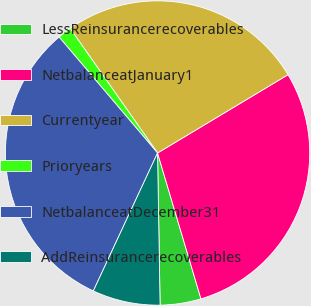Convert chart to OTSL. <chart><loc_0><loc_0><loc_500><loc_500><pie_chart><fcel>LessReinsurancerecoverables<fcel>NetbalanceatJanuary1<fcel>Currentyear<fcel>Prioryears<fcel>NetbalanceatDecember31<fcel>AddReinsurancerecoverables<nl><fcel>4.34%<fcel>29.0%<fcel>26.13%<fcel>1.47%<fcel>31.86%<fcel>7.2%<nl></chart> 